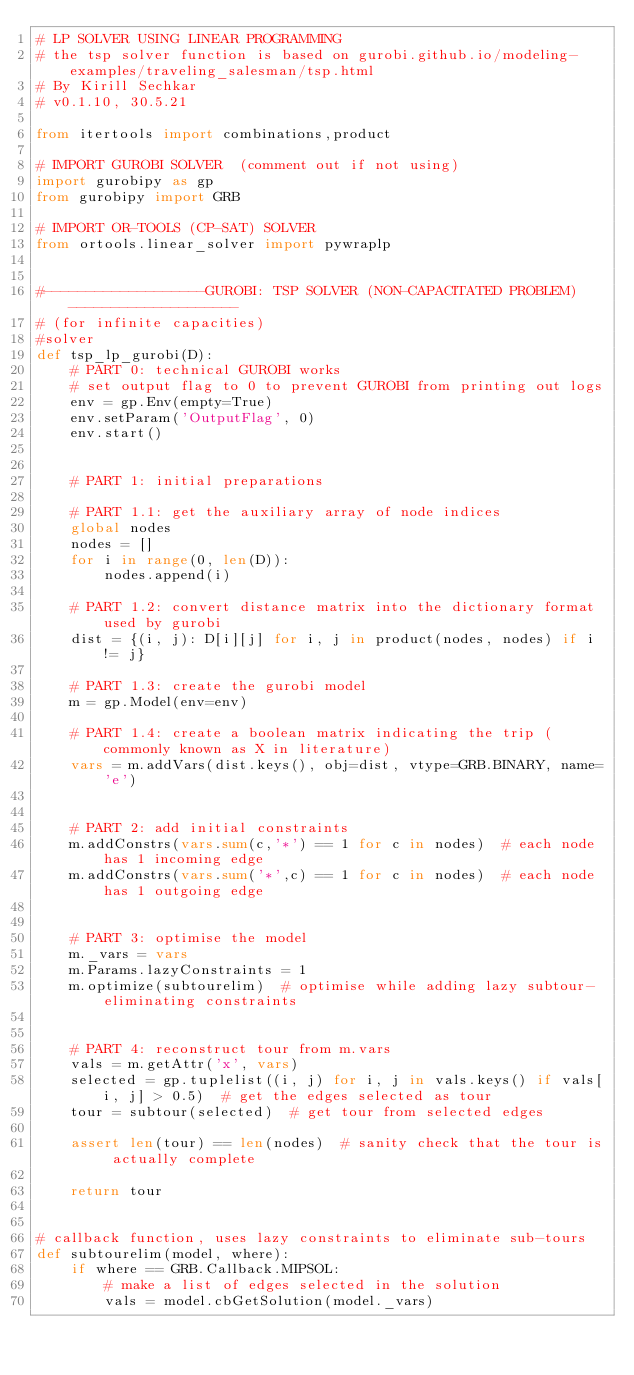<code> <loc_0><loc_0><loc_500><loc_500><_Python_># LP SOLVER USING LINEAR PROGRAMMING
# the tsp solver function is based on gurobi.github.io/modeling-examples/traveling_salesman/tsp.html
# By Kirill Sechkar
# v0.1.10, 30.5.21

from itertools import combinations,product

# IMPORT GUROBI SOLVER  (comment out if not using)
import gurobipy as gp
from gurobipy import GRB

# IMPORT OR-TOOLS (CP-SAT) SOLVER
from ortools.linear_solver import pywraplp


#-------------------GUROBI: TSP SOLVER (NON-CAPACITATED PROBLEM)--------------------
# (for infinite capacities)
#solver
def tsp_lp_gurobi(D):
    # PART 0: technical GUROBI works
    # set output flag to 0 to prevent GUROBI from printing out logs
    env = gp.Env(empty=True)
    env.setParam('OutputFlag', 0)
    env.start()


    # PART 1: initial preparations

    # PART 1.1: get the auxiliary array of node indices
    global nodes
    nodes = []
    for i in range(0, len(D)):
        nodes.append(i)

    # PART 1.2: convert distance matrix into the dictionary format used by gurobi
    dist = {(i, j): D[i][j] for i, j in product(nodes, nodes) if i != j}

    # PART 1.3: create the gurobi model
    m = gp.Model(env=env)

    # PART 1.4: create a boolean matrix indicating the trip (commonly known as X in literature)
    vars = m.addVars(dist.keys(), obj=dist, vtype=GRB.BINARY, name='e')


    # PART 2: add initial constraints
    m.addConstrs(vars.sum(c,'*') == 1 for c in nodes)  # each node has 1 incoming edge
    m.addConstrs(vars.sum('*',c) == 1 for c in nodes)  # each node has 1 outgoing edge


    # PART 3: optimise the model
    m._vars = vars
    m.Params.lazyConstraints = 1
    m.optimize(subtourelim)  # optimise while adding lazy subtour-eliminating constraints


    # PART 4: reconstruct tour from m.vars
    vals = m.getAttr('x', vars)
    selected = gp.tuplelist((i, j) for i, j in vals.keys() if vals[i, j] > 0.5)  # get the edges selected as tour
    tour = subtour(selected)  # get tour from selected edges

    assert len(tour) == len(nodes)  # sanity check that the tour is actually complete

    return tour


# callback function, uses lazy constraints to eliminate sub-tours
def subtourelim(model, where):
    if where == GRB.Callback.MIPSOL:
        # make a list of edges selected in the solution
        vals = model.cbGetSolution(model._vars)</code> 